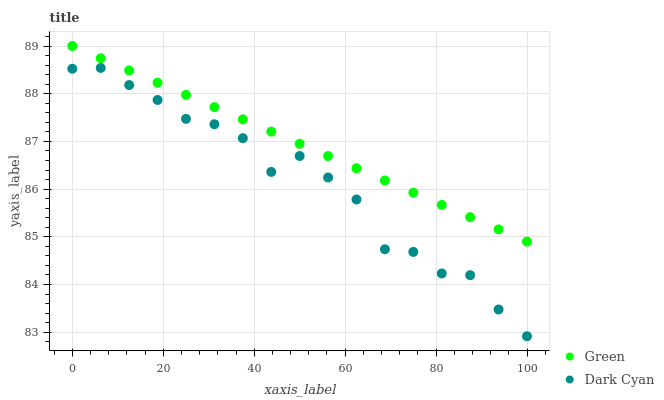Does Dark Cyan have the minimum area under the curve?
Answer yes or no. Yes. Does Green have the maximum area under the curve?
Answer yes or no. Yes. Does Green have the minimum area under the curve?
Answer yes or no. No. Is Green the smoothest?
Answer yes or no. Yes. Is Dark Cyan the roughest?
Answer yes or no. Yes. Is Green the roughest?
Answer yes or no. No. Does Dark Cyan have the lowest value?
Answer yes or no. Yes. Does Green have the lowest value?
Answer yes or no. No. Does Green have the highest value?
Answer yes or no. Yes. Is Dark Cyan less than Green?
Answer yes or no. Yes. Is Green greater than Dark Cyan?
Answer yes or no. Yes. Does Dark Cyan intersect Green?
Answer yes or no. No. 